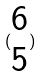Convert formula to latex. <formula><loc_0><loc_0><loc_500><loc_500>( \begin{matrix} 6 \\ 5 \end{matrix} )</formula> 